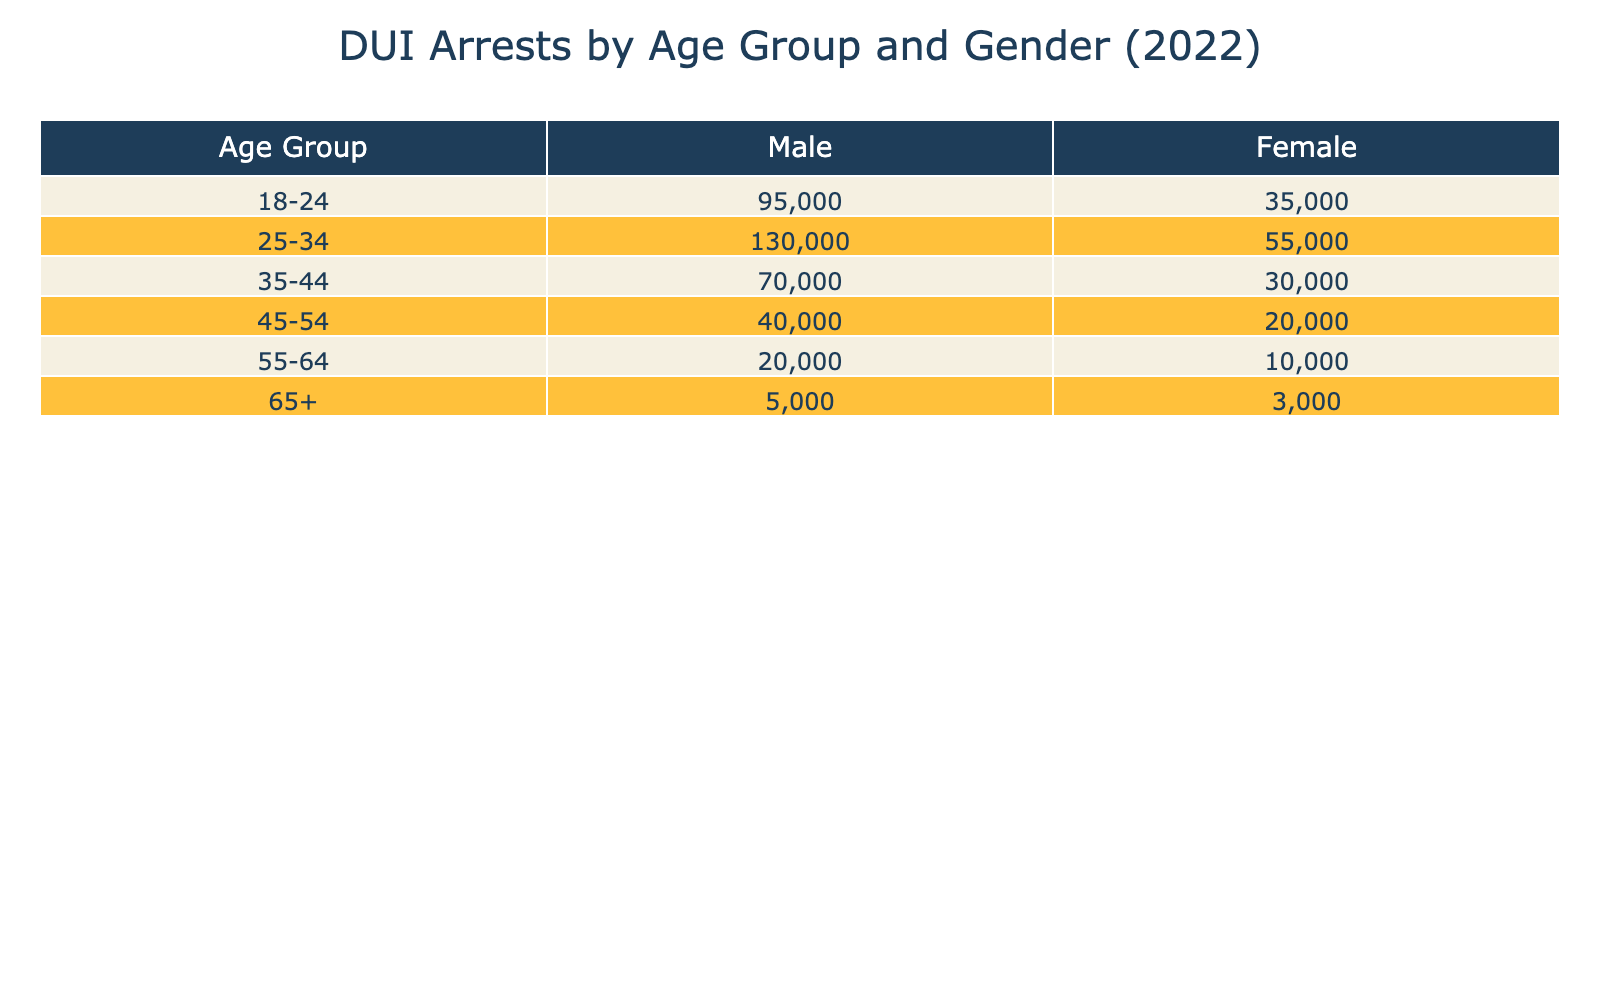What is the total number of DUI arrests for males aged 25-34? According to the table, the number of DUI arrests for males in the 25-34 age group is 130,000.
Answer: 130,000 What is the total number of DUI arrests for females across all age groups? By summing up the arrests for females in each age group: 35,000 (18-24) + 55,000 (25-34) + 30,000 (35-44) + 20,000 (45-54) + 10,000 (55-64) + 3,000 (65+) = 153,000.
Answer: 153,000 Which age group has the highest number of DUI arrests for females? The age group 25-34 has the highest DUI arrests for females with 55,000.
Answer: 25-34 What is the difference in DUI arrests between males and females in the 35-44 age group? For males in the 35-44 age group, there are 70,000 arrests, while for females there are 30,000 arrests. The difference is 70,000 - 30,000 = 40,000.
Answer: 40,000 Are there more DUI arrests for males aged 55-64 compared to females in the same age group? Males aged 55-64 have 20,000 arrests, while females have 10,000 arrests. Since 20,000 > 10,000, the statement is true.
Answer: Yes What is the average number of DUI arrests for females in all age groups? Adding all female DUI arrests: 35,000 (18-24) + 55,000 (25-34) + 30,000 (35-44) + 20,000 (45-54) + 10,000 (55-64) + 3,000 (65+) = 153,000. There are 6 age groups, so the average is 153,000 / 6 = 25,500.
Answer: 25,500 Which age group has the least number of DUI arrests for both genders combined? Combining the arrests for all age groups gives: 18-24: 95000 + 35000 = 130000, 25-34: 130000 + 55000 = 185000, 35-44: 70000 + 30000 = 100000, 45-54: 40000 + 20000 = 60000, 55-64: 20000 + 10000 = 30000, 65+: 5000 + 3000 = 8000. The age group 65+ has the least arrests at 8,000.
Answer: 65+ If we only consider the 18-24 age group, how many more DUI arrests are there for males compared to females? For the 18-24 age group, males have 95,000 arrests and females have 35,000. The difference is 95,000 - 35,000 = 60,000.
Answer: 60,000 What percentage of total DUI arrests in the 25-34 age group are attributed to females? The total arrests for the 25-34 age group are 130,000 (males) + 55,000 (females) = 185,000. Female arrests are 55,000, so the percentage is (55,000 / 185,000) * 100 ≈ 29.73%.
Answer: Approximately 29.73% Is the combined number of DUI arrests for males aged 45-54 greater than the combined arrests for females aged 25-34? Males aged 45-54 have 40,000 arrests and females aged 25-34 have 55,000 arrests. Thus, 40,000 < 55,000, so the statement is false.
Answer: No 